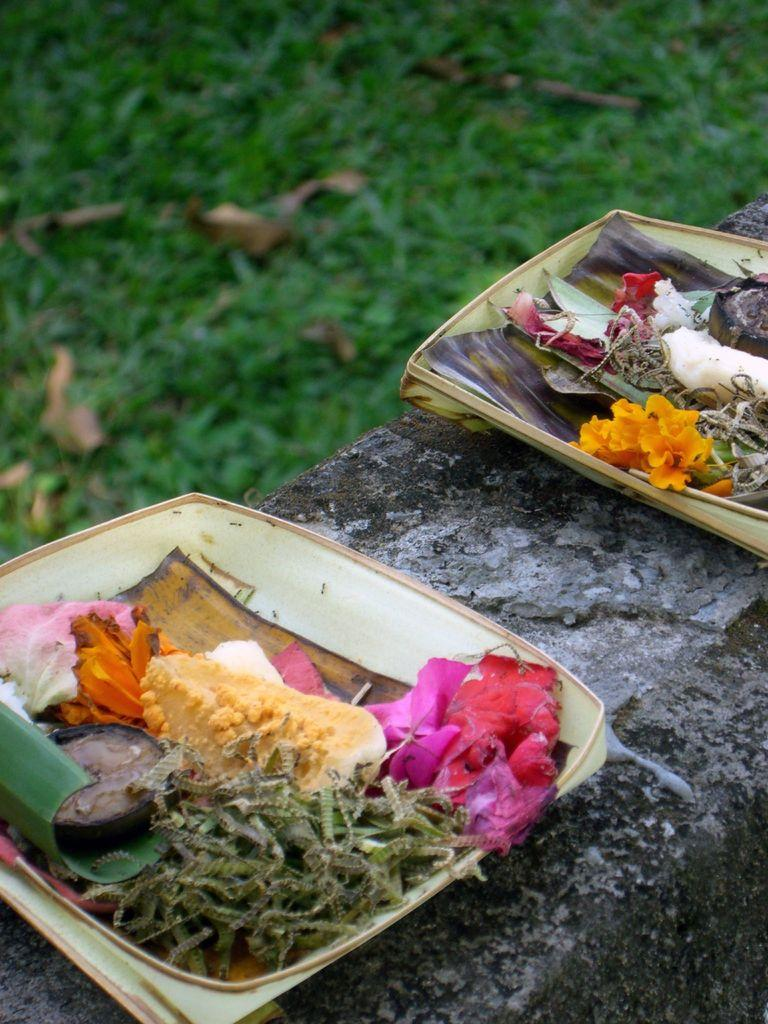What type of living organisms can be seen in the image? There are flowers in the image. What else can be seen in the image besides the flowers? There are other objects in the image. What is visible in the background of the image? The background of the image includes grass. How would you describe the background of the image? The background of the image is blurred. What is the name of the person who owns the cellar in the image? There is no cellar or person mentioned in the image; it features flowers and other objects. 